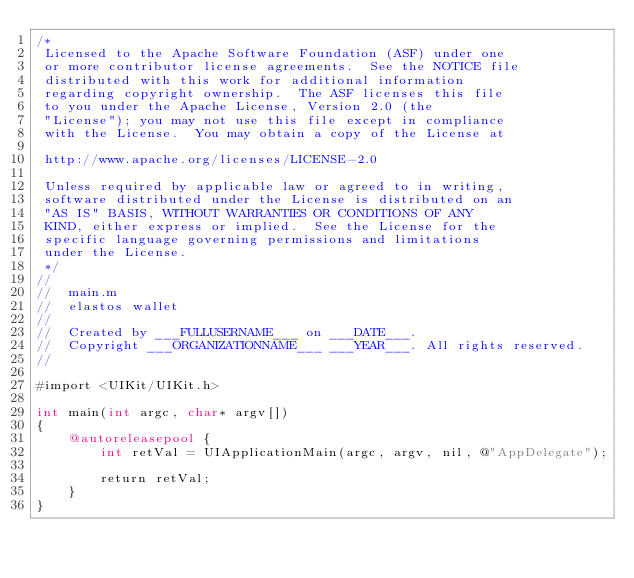Convert code to text. <code><loc_0><loc_0><loc_500><loc_500><_ObjectiveC_>/*
 Licensed to the Apache Software Foundation (ASF) under one
 or more contributor license agreements.  See the NOTICE file
 distributed with this work for additional information
 regarding copyright ownership.  The ASF licenses this file
 to you under the Apache License, Version 2.0 (the
 "License"); you may not use this file except in compliance
 with the License.  You may obtain a copy of the License at

 http://www.apache.org/licenses/LICENSE-2.0

 Unless required by applicable law or agreed to in writing,
 software distributed under the License is distributed on an
 "AS IS" BASIS, WITHOUT WARRANTIES OR CONDITIONS OF ANY
 KIND, either express or implied.  See the License for the
 specific language governing permissions and limitations
 under the License.
 */
//
//  main.m
//  elastos wallet
//
//  Created by ___FULLUSERNAME___ on ___DATE___.
//  Copyright ___ORGANIZATIONNAME___ ___YEAR___. All rights reserved.
//

#import <UIKit/UIKit.h>

int main(int argc, char* argv[])
{
    @autoreleasepool {
        int retVal = UIApplicationMain(argc, argv, nil, @"AppDelegate");
        
        return retVal;
    }
}
</code> 